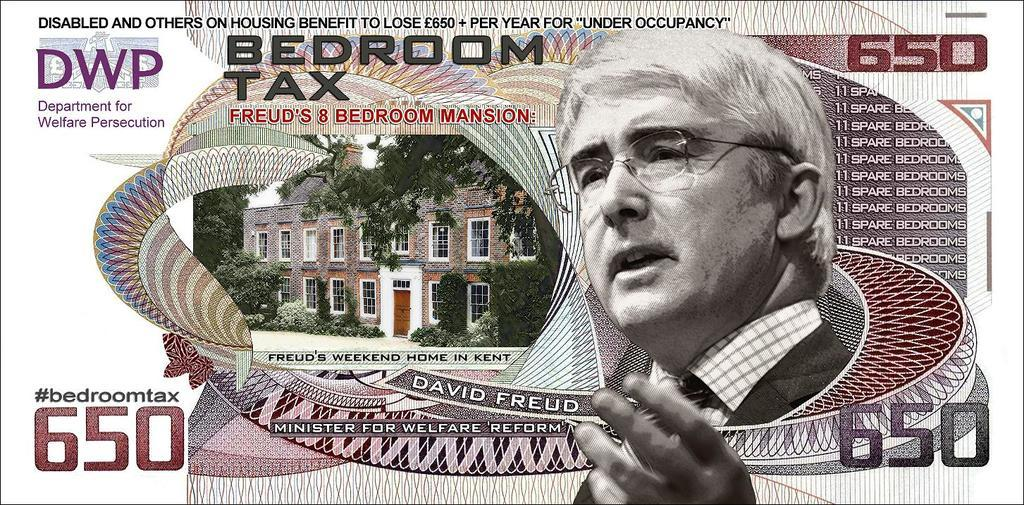What type of object is shown in the image? The image is of a currency note. What is depicted on the currency note? There is a building and a picture of a man on the currency note. Where is the text located on the currency note? The text is at the top of the currency note. How many icicles are hanging from the building on the currency note? There are no icicles present on the currency note, as it features a building and a man, but no icicles. What type of fruit is the man holding in the image? The man on the currency note is not holding any fruit, such as a quince, in the image. 